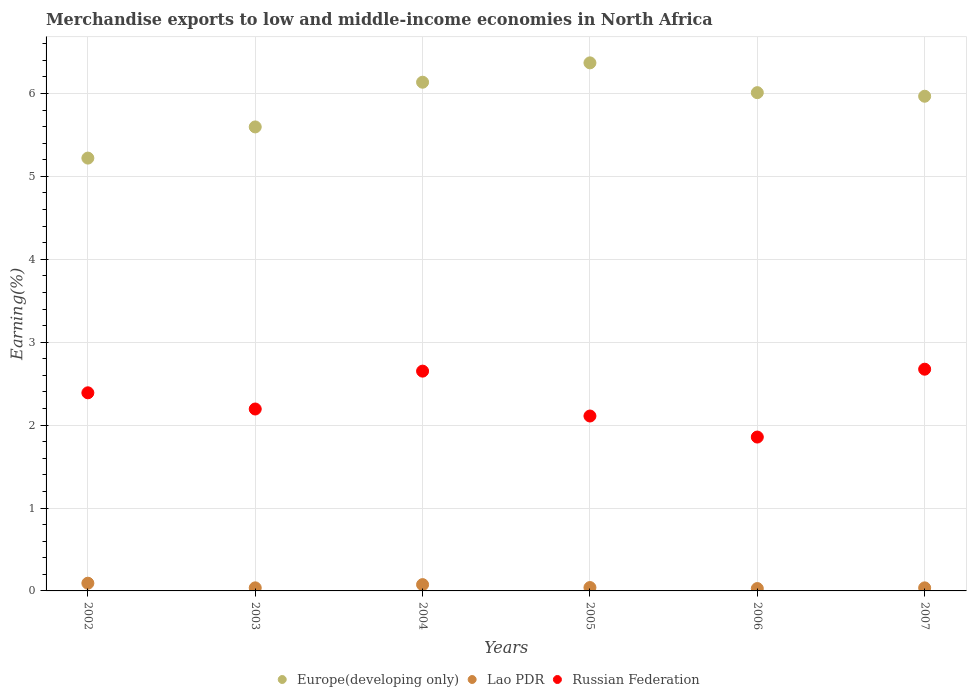Is the number of dotlines equal to the number of legend labels?
Offer a terse response. Yes. What is the percentage of amount earned from merchandise exports in Lao PDR in 2002?
Offer a very short reply. 0.09. Across all years, what is the maximum percentage of amount earned from merchandise exports in Lao PDR?
Offer a terse response. 0.09. Across all years, what is the minimum percentage of amount earned from merchandise exports in Lao PDR?
Give a very brief answer. 0.03. What is the total percentage of amount earned from merchandise exports in Russian Federation in the graph?
Keep it short and to the point. 13.87. What is the difference between the percentage of amount earned from merchandise exports in Europe(developing only) in 2004 and that in 2005?
Your response must be concise. -0.23. What is the difference between the percentage of amount earned from merchandise exports in Europe(developing only) in 2002 and the percentage of amount earned from merchandise exports in Lao PDR in 2007?
Your response must be concise. 5.18. What is the average percentage of amount earned from merchandise exports in Russian Federation per year?
Make the answer very short. 2.31. In the year 2005, what is the difference between the percentage of amount earned from merchandise exports in Europe(developing only) and percentage of amount earned from merchandise exports in Lao PDR?
Your answer should be compact. 6.33. What is the ratio of the percentage of amount earned from merchandise exports in Russian Federation in 2005 to that in 2007?
Make the answer very short. 0.79. Is the percentage of amount earned from merchandise exports in Russian Federation in 2002 less than that in 2006?
Your response must be concise. No. Is the difference between the percentage of amount earned from merchandise exports in Europe(developing only) in 2002 and 2005 greater than the difference between the percentage of amount earned from merchandise exports in Lao PDR in 2002 and 2005?
Your answer should be compact. No. What is the difference between the highest and the second highest percentage of amount earned from merchandise exports in Russian Federation?
Provide a short and direct response. 0.02. What is the difference between the highest and the lowest percentage of amount earned from merchandise exports in Europe(developing only)?
Your response must be concise. 1.15. Does the percentage of amount earned from merchandise exports in Lao PDR monotonically increase over the years?
Your response must be concise. No. Is the percentage of amount earned from merchandise exports in Europe(developing only) strictly greater than the percentage of amount earned from merchandise exports in Lao PDR over the years?
Offer a very short reply. Yes. Is the percentage of amount earned from merchandise exports in Lao PDR strictly less than the percentage of amount earned from merchandise exports in Europe(developing only) over the years?
Offer a very short reply. Yes. How many dotlines are there?
Your answer should be very brief. 3. How many years are there in the graph?
Keep it short and to the point. 6. Are the values on the major ticks of Y-axis written in scientific E-notation?
Offer a very short reply. No. Does the graph contain grids?
Offer a terse response. Yes. What is the title of the graph?
Keep it short and to the point. Merchandise exports to low and middle-income economies in North Africa. What is the label or title of the Y-axis?
Your answer should be compact. Earning(%). What is the Earning(%) in Europe(developing only) in 2002?
Your response must be concise. 5.22. What is the Earning(%) in Lao PDR in 2002?
Your answer should be very brief. 0.09. What is the Earning(%) in Russian Federation in 2002?
Your response must be concise. 2.39. What is the Earning(%) of Europe(developing only) in 2003?
Offer a terse response. 5.6. What is the Earning(%) in Lao PDR in 2003?
Make the answer very short. 0.04. What is the Earning(%) in Russian Federation in 2003?
Give a very brief answer. 2.19. What is the Earning(%) of Europe(developing only) in 2004?
Provide a short and direct response. 6.14. What is the Earning(%) in Lao PDR in 2004?
Offer a very short reply. 0.08. What is the Earning(%) of Russian Federation in 2004?
Ensure brevity in your answer.  2.65. What is the Earning(%) of Europe(developing only) in 2005?
Offer a terse response. 6.37. What is the Earning(%) in Lao PDR in 2005?
Offer a very short reply. 0.04. What is the Earning(%) of Russian Federation in 2005?
Ensure brevity in your answer.  2.11. What is the Earning(%) of Europe(developing only) in 2006?
Offer a very short reply. 6.01. What is the Earning(%) in Lao PDR in 2006?
Your response must be concise. 0.03. What is the Earning(%) of Russian Federation in 2006?
Give a very brief answer. 1.86. What is the Earning(%) of Europe(developing only) in 2007?
Keep it short and to the point. 5.97. What is the Earning(%) of Lao PDR in 2007?
Offer a terse response. 0.04. What is the Earning(%) of Russian Federation in 2007?
Give a very brief answer. 2.67. Across all years, what is the maximum Earning(%) in Europe(developing only)?
Offer a terse response. 6.37. Across all years, what is the maximum Earning(%) in Lao PDR?
Offer a very short reply. 0.09. Across all years, what is the maximum Earning(%) of Russian Federation?
Your answer should be very brief. 2.67. Across all years, what is the minimum Earning(%) of Europe(developing only)?
Your response must be concise. 5.22. Across all years, what is the minimum Earning(%) in Lao PDR?
Keep it short and to the point. 0.03. Across all years, what is the minimum Earning(%) of Russian Federation?
Your response must be concise. 1.86. What is the total Earning(%) of Europe(developing only) in the graph?
Your answer should be very brief. 35.3. What is the total Earning(%) in Lao PDR in the graph?
Make the answer very short. 0.31. What is the total Earning(%) in Russian Federation in the graph?
Make the answer very short. 13.87. What is the difference between the Earning(%) of Europe(developing only) in 2002 and that in 2003?
Keep it short and to the point. -0.38. What is the difference between the Earning(%) of Lao PDR in 2002 and that in 2003?
Provide a short and direct response. 0.06. What is the difference between the Earning(%) of Russian Federation in 2002 and that in 2003?
Your response must be concise. 0.2. What is the difference between the Earning(%) in Europe(developing only) in 2002 and that in 2004?
Ensure brevity in your answer.  -0.92. What is the difference between the Earning(%) of Lao PDR in 2002 and that in 2004?
Ensure brevity in your answer.  0.02. What is the difference between the Earning(%) in Russian Federation in 2002 and that in 2004?
Offer a very short reply. -0.26. What is the difference between the Earning(%) of Europe(developing only) in 2002 and that in 2005?
Your response must be concise. -1.15. What is the difference between the Earning(%) of Lao PDR in 2002 and that in 2005?
Provide a short and direct response. 0.05. What is the difference between the Earning(%) of Russian Federation in 2002 and that in 2005?
Make the answer very short. 0.28. What is the difference between the Earning(%) in Europe(developing only) in 2002 and that in 2006?
Offer a very short reply. -0.79. What is the difference between the Earning(%) in Lao PDR in 2002 and that in 2006?
Your answer should be compact. 0.06. What is the difference between the Earning(%) of Russian Federation in 2002 and that in 2006?
Your response must be concise. 0.53. What is the difference between the Earning(%) of Europe(developing only) in 2002 and that in 2007?
Offer a very short reply. -0.75. What is the difference between the Earning(%) in Lao PDR in 2002 and that in 2007?
Offer a terse response. 0.06. What is the difference between the Earning(%) in Russian Federation in 2002 and that in 2007?
Provide a short and direct response. -0.28. What is the difference between the Earning(%) of Europe(developing only) in 2003 and that in 2004?
Offer a terse response. -0.54. What is the difference between the Earning(%) of Lao PDR in 2003 and that in 2004?
Provide a succinct answer. -0.04. What is the difference between the Earning(%) in Russian Federation in 2003 and that in 2004?
Ensure brevity in your answer.  -0.46. What is the difference between the Earning(%) in Europe(developing only) in 2003 and that in 2005?
Offer a terse response. -0.77. What is the difference between the Earning(%) of Lao PDR in 2003 and that in 2005?
Your answer should be compact. -0. What is the difference between the Earning(%) of Russian Federation in 2003 and that in 2005?
Your response must be concise. 0.08. What is the difference between the Earning(%) in Europe(developing only) in 2003 and that in 2006?
Your answer should be compact. -0.41. What is the difference between the Earning(%) in Lao PDR in 2003 and that in 2006?
Make the answer very short. 0.01. What is the difference between the Earning(%) in Russian Federation in 2003 and that in 2006?
Provide a succinct answer. 0.34. What is the difference between the Earning(%) of Europe(developing only) in 2003 and that in 2007?
Your answer should be very brief. -0.37. What is the difference between the Earning(%) in Lao PDR in 2003 and that in 2007?
Your answer should be very brief. 0. What is the difference between the Earning(%) of Russian Federation in 2003 and that in 2007?
Provide a succinct answer. -0.48. What is the difference between the Earning(%) in Europe(developing only) in 2004 and that in 2005?
Give a very brief answer. -0.23. What is the difference between the Earning(%) of Lao PDR in 2004 and that in 2005?
Make the answer very short. 0.04. What is the difference between the Earning(%) of Russian Federation in 2004 and that in 2005?
Give a very brief answer. 0.54. What is the difference between the Earning(%) in Europe(developing only) in 2004 and that in 2006?
Offer a terse response. 0.13. What is the difference between the Earning(%) of Lao PDR in 2004 and that in 2006?
Keep it short and to the point. 0.05. What is the difference between the Earning(%) in Russian Federation in 2004 and that in 2006?
Make the answer very short. 0.8. What is the difference between the Earning(%) in Europe(developing only) in 2004 and that in 2007?
Give a very brief answer. 0.17. What is the difference between the Earning(%) of Lao PDR in 2004 and that in 2007?
Offer a very short reply. 0.04. What is the difference between the Earning(%) in Russian Federation in 2004 and that in 2007?
Your answer should be compact. -0.02. What is the difference between the Earning(%) in Europe(developing only) in 2005 and that in 2006?
Make the answer very short. 0.36. What is the difference between the Earning(%) of Lao PDR in 2005 and that in 2006?
Your answer should be compact. 0.01. What is the difference between the Earning(%) of Russian Federation in 2005 and that in 2006?
Your answer should be compact. 0.25. What is the difference between the Earning(%) of Europe(developing only) in 2005 and that in 2007?
Your answer should be compact. 0.4. What is the difference between the Earning(%) of Lao PDR in 2005 and that in 2007?
Your answer should be compact. 0. What is the difference between the Earning(%) of Russian Federation in 2005 and that in 2007?
Your response must be concise. -0.56. What is the difference between the Earning(%) of Europe(developing only) in 2006 and that in 2007?
Ensure brevity in your answer.  0.04. What is the difference between the Earning(%) in Lao PDR in 2006 and that in 2007?
Give a very brief answer. -0.01. What is the difference between the Earning(%) in Russian Federation in 2006 and that in 2007?
Provide a short and direct response. -0.82. What is the difference between the Earning(%) of Europe(developing only) in 2002 and the Earning(%) of Lao PDR in 2003?
Keep it short and to the point. 5.18. What is the difference between the Earning(%) in Europe(developing only) in 2002 and the Earning(%) in Russian Federation in 2003?
Your response must be concise. 3.03. What is the difference between the Earning(%) in Lao PDR in 2002 and the Earning(%) in Russian Federation in 2003?
Your answer should be very brief. -2.1. What is the difference between the Earning(%) of Europe(developing only) in 2002 and the Earning(%) of Lao PDR in 2004?
Give a very brief answer. 5.14. What is the difference between the Earning(%) of Europe(developing only) in 2002 and the Earning(%) of Russian Federation in 2004?
Your response must be concise. 2.57. What is the difference between the Earning(%) in Lao PDR in 2002 and the Earning(%) in Russian Federation in 2004?
Your response must be concise. -2.56. What is the difference between the Earning(%) in Europe(developing only) in 2002 and the Earning(%) in Lao PDR in 2005?
Make the answer very short. 5.18. What is the difference between the Earning(%) in Europe(developing only) in 2002 and the Earning(%) in Russian Federation in 2005?
Your answer should be very brief. 3.11. What is the difference between the Earning(%) in Lao PDR in 2002 and the Earning(%) in Russian Federation in 2005?
Your answer should be very brief. -2.02. What is the difference between the Earning(%) in Europe(developing only) in 2002 and the Earning(%) in Lao PDR in 2006?
Provide a succinct answer. 5.19. What is the difference between the Earning(%) of Europe(developing only) in 2002 and the Earning(%) of Russian Federation in 2006?
Ensure brevity in your answer.  3.36. What is the difference between the Earning(%) in Lao PDR in 2002 and the Earning(%) in Russian Federation in 2006?
Give a very brief answer. -1.76. What is the difference between the Earning(%) of Europe(developing only) in 2002 and the Earning(%) of Lao PDR in 2007?
Your answer should be compact. 5.18. What is the difference between the Earning(%) in Europe(developing only) in 2002 and the Earning(%) in Russian Federation in 2007?
Make the answer very short. 2.55. What is the difference between the Earning(%) in Lao PDR in 2002 and the Earning(%) in Russian Federation in 2007?
Offer a very short reply. -2.58. What is the difference between the Earning(%) of Europe(developing only) in 2003 and the Earning(%) of Lao PDR in 2004?
Your response must be concise. 5.52. What is the difference between the Earning(%) of Europe(developing only) in 2003 and the Earning(%) of Russian Federation in 2004?
Offer a very short reply. 2.95. What is the difference between the Earning(%) in Lao PDR in 2003 and the Earning(%) in Russian Federation in 2004?
Your answer should be very brief. -2.61. What is the difference between the Earning(%) of Europe(developing only) in 2003 and the Earning(%) of Lao PDR in 2005?
Give a very brief answer. 5.56. What is the difference between the Earning(%) in Europe(developing only) in 2003 and the Earning(%) in Russian Federation in 2005?
Offer a very short reply. 3.49. What is the difference between the Earning(%) in Lao PDR in 2003 and the Earning(%) in Russian Federation in 2005?
Offer a terse response. -2.07. What is the difference between the Earning(%) of Europe(developing only) in 2003 and the Earning(%) of Lao PDR in 2006?
Provide a short and direct response. 5.57. What is the difference between the Earning(%) in Europe(developing only) in 2003 and the Earning(%) in Russian Federation in 2006?
Your response must be concise. 3.74. What is the difference between the Earning(%) of Lao PDR in 2003 and the Earning(%) of Russian Federation in 2006?
Your answer should be compact. -1.82. What is the difference between the Earning(%) in Europe(developing only) in 2003 and the Earning(%) in Lao PDR in 2007?
Offer a very short reply. 5.56. What is the difference between the Earning(%) in Europe(developing only) in 2003 and the Earning(%) in Russian Federation in 2007?
Provide a succinct answer. 2.92. What is the difference between the Earning(%) in Lao PDR in 2003 and the Earning(%) in Russian Federation in 2007?
Your response must be concise. -2.64. What is the difference between the Earning(%) of Europe(developing only) in 2004 and the Earning(%) of Lao PDR in 2005?
Keep it short and to the point. 6.09. What is the difference between the Earning(%) of Europe(developing only) in 2004 and the Earning(%) of Russian Federation in 2005?
Your answer should be very brief. 4.03. What is the difference between the Earning(%) in Lao PDR in 2004 and the Earning(%) in Russian Federation in 2005?
Your answer should be compact. -2.03. What is the difference between the Earning(%) of Europe(developing only) in 2004 and the Earning(%) of Lao PDR in 2006?
Your answer should be compact. 6.11. What is the difference between the Earning(%) in Europe(developing only) in 2004 and the Earning(%) in Russian Federation in 2006?
Provide a succinct answer. 4.28. What is the difference between the Earning(%) of Lao PDR in 2004 and the Earning(%) of Russian Federation in 2006?
Ensure brevity in your answer.  -1.78. What is the difference between the Earning(%) in Europe(developing only) in 2004 and the Earning(%) in Lao PDR in 2007?
Offer a very short reply. 6.1. What is the difference between the Earning(%) of Europe(developing only) in 2004 and the Earning(%) of Russian Federation in 2007?
Make the answer very short. 3.46. What is the difference between the Earning(%) of Lao PDR in 2004 and the Earning(%) of Russian Federation in 2007?
Ensure brevity in your answer.  -2.6. What is the difference between the Earning(%) of Europe(developing only) in 2005 and the Earning(%) of Lao PDR in 2006?
Your answer should be very brief. 6.34. What is the difference between the Earning(%) in Europe(developing only) in 2005 and the Earning(%) in Russian Federation in 2006?
Give a very brief answer. 4.51. What is the difference between the Earning(%) of Lao PDR in 2005 and the Earning(%) of Russian Federation in 2006?
Your answer should be very brief. -1.82. What is the difference between the Earning(%) in Europe(developing only) in 2005 and the Earning(%) in Lao PDR in 2007?
Your response must be concise. 6.33. What is the difference between the Earning(%) of Europe(developing only) in 2005 and the Earning(%) of Russian Federation in 2007?
Keep it short and to the point. 3.69. What is the difference between the Earning(%) in Lao PDR in 2005 and the Earning(%) in Russian Federation in 2007?
Keep it short and to the point. -2.63. What is the difference between the Earning(%) in Europe(developing only) in 2006 and the Earning(%) in Lao PDR in 2007?
Offer a terse response. 5.97. What is the difference between the Earning(%) of Europe(developing only) in 2006 and the Earning(%) of Russian Federation in 2007?
Provide a short and direct response. 3.34. What is the difference between the Earning(%) of Lao PDR in 2006 and the Earning(%) of Russian Federation in 2007?
Offer a terse response. -2.65. What is the average Earning(%) of Europe(developing only) per year?
Offer a very short reply. 5.88. What is the average Earning(%) of Lao PDR per year?
Your answer should be compact. 0.05. What is the average Earning(%) of Russian Federation per year?
Keep it short and to the point. 2.31. In the year 2002, what is the difference between the Earning(%) of Europe(developing only) and Earning(%) of Lao PDR?
Provide a succinct answer. 5.13. In the year 2002, what is the difference between the Earning(%) of Europe(developing only) and Earning(%) of Russian Federation?
Give a very brief answer. 2.83. In the year 2002, what is the difference between the Earning(%) of Lao PDR and Earning(%) of Russian Federation?
Keep it short and to the point. -2.3. In the year 2003, what is the difference between the Earning(%) in Europe(developing only) and Earning(%) in Lao PDR?
Your answer should be very brief. 5.56. In the year 2003, what is the difference between the Earning(%) in Europe(developing only) and Earning(%) in Russian Federation?
Your answer should be compact. 3.4. In the year 2003, what is the difference between the Earning(%) in Lao PDR and Earning(%) in Russian Federation?
Provide a succinct answer. -2.16. In the year 2004, what is the difference between the Earning(%) in Europe(developing only) and Earning(%) in Lao PDR?
Provide a succinct answer. 6.06. In the year 2004, what is the difference between the Earning(%) in Europe(developing only) and Earning(%) in Russian Federation?
Ensure brevity in your answer.  3.48. In the year 2004, what is the difference between the Earning(%) in Lao PDR and Earning(%) in Russian Federation?
Keep it short and to the point. -2.57. In the year 2005, what is the difference between the Earning(%) in Europe(developing only) and Earning(%) in Lao PDR?
Offer a very short reply. 6.33. In the year 2005, what is the difference between the Earning(%) in Europe(developing only) and Earning(%) in Russian Federation?
Give a very brief answer. 4.26. In the year 2005, what is the difference between the Earning(%) of Lao PDR and Earning(%) of Russian Federation?
Your response must be concise. -2.07. In the year 2006, what is the difference between the Earning(%) in Europe(developing only) and Earning(%) in Lao PDR?
Provide a succinct answer. 5.98. In the year 2006, what is the difference between the Earning(%) in Europe(developing only) and Earning(%) in Russian Federation?
Make the answer very short. 4.15. In the year 2006, what is the difference between the Earning(%) of Lao PDR and Earning(%) of Russian Federation?
Make the answer very short. -1.83. In the year 2007, what is the difference between the Earning(%) in Europe(developing only) and Earning(%) in Lao PDR?
Your response must be concise. 5.93. In the year 2007, what is the difference between the Earning(%) of Europe(developing only) and Earning(%) of Russian Federation?
Make the answer very short. 3.29. In the year 2007, what is the difference between the Earning(%) of Lao PDR and Earning(%) of Russian Federation?
Offer a terse response. -2.64. What is the ratio of the Earning(%) of Europe(developing only) in 2002 to that in 2003?
Provide a succinct answer. 0.93. What is the ratio of the Earning(%) of Lao PDR in 2002 to that in 2003?
Provide a succinct answer. 2.51. What is the ratio of the Earning(%) of Russian Federation in 2002 to that in 2003?
Provide a succinct answer. 1.09. What is the ratio of the Earning(%) of Europe(developing only) in 2002 to that in 2004?
Make the answer very short. 0.85. What is the ratio of the Earning(%) of Lao PDR in 2002 to that in 2004?
Your answer should be compact. 1.23. What is the ratio of the Earning(%) in Russian Federation in 2002 to that in 2004?
Offer a terse response. 0.9. What is the ratio of the Earning(%) in Europe(developing only) in 2002 to that in 2005?
Your answer should be very brief. 0.82. What is the ratio of the Earning(%) in Lao PDR in 2002 to that in 2005?
Your answer should be very brief. 2.29. What is the ratio of the Earning(%) in Russian Federation in 2002 to that in 2005?
Offer a very short reply. 1.13. What is the ratio of the Earning(%) of Europe(developing only) in 2002 to that in 2006?
Give a very brief answer. 0.87. What is the ratio of the Earning(%) in Lao PDR in 2002 to that in 2006?
Ensure brevity in your answer.  3.25. What is the ratio of the Earning(%) of Russian Federation in 2002 to that in 2006?
Offer a terse response. 1.29. What is the ratio of the Earning(%) in Europe(developing only) in 2002 to that in 2007?
Offer a terse response. 0.87. What is the ratio of the Earning(%) of Lao PDR in 2002 to that in 2007?
Your response must be concise. 2.52. What is the ratio of the Earning(%) of Russian Federation in 2002 to that in 2007?
Provide a short and direct response. 0.89. What is the ratio of the Earning(%) in Europe(developing only) in 2003 to that in 2004?
Your answer should be very brief. 0.91. What is the ratio of the Earning(%) in Lao PDR in 2003 to that in 2004?
Keep it short and to the point. 0.49. What is the ratio of the Earning(%) of Russian Federation in 2003 to that in 2004?
Provide a succinct answer. 0.83. What is the ratio of the Earning(%) in Europe(developing only) in 2003 to that in 2005?
Provide a succinct answer. 0.88. What is the ratio of the Earning(%) of Lao PDR in 2003 to that in 2005?
Make the answer very short. 0.91. What is the ratio of the Earning(%) of Russian Federation in 2003 to that in 2005?
Your answer should be compact. 1.04. What is the ratio of the Earning(%) in Europe(developing only) in 2003 to that in 2006?
Give a very brief answer. 0.93. What is the ratio of the Earning(%) in Lao PDR in 2003 to that in 2006?
Offer a terse response. 1.29. What is the ratio of the Earning(%) in Russian Federation in 2003 to that in 2006?
Ensure brevity in your answer.  1.18. What is the ratio of the Earning(%) of Europe(developing only) in 2003 to that in 2007?
Ensure brevity in your answer.  0.94. What is the ratio of the Earning(%) of Lao PDR in 2003 to that in 2007?
Ensure brevity in your answer.  1. What is the ratio of the Earning(%) of Russian Federation in 2003 to that in 2007?
Provide a short and direct response. 0.82. What is the ratio of the Earning(%) of Europe(developing only) in 2004 to that in 2005?
Ensure brevity in your answer.  0.96. What is the ratio of the Earning(%) in Lao PDR in 2004 to that in 2005?
Ensure brevity in your answer.  1.87. What is the ratio of the Earning(%) in Russian Federation in 2004 to that in 2005?
Your response must be concise. 1.26. What is the ratio of the Earning(%) of Lao PDR in 2004 to that in 2006?
Give a very brief answer. 2.65. What is the ratio of the Earning(%) of Russian Federation in 2004 to that in 2006?
Your answer should be compact. 1.43. What is the ratio of the Earning(%) of Europe(developing only) in 2004 to that in 2007?
Provide a succinct answer. 1.03. What is the ratio of the Earning(%) in Lao PDR in 2004 to that in 2007?
Your answer should be compact. 2.06. What is the ratio of the Earning(%) in Europe(developing only) in 2005 to that in 2006?
Offer a terse response. 1.06. What is the ratio of the Earning(%) of Lao PDR in 2005 to that in 2006?
Provide a short and direct response. 1.42. What is the ratio of the Earning(%) in Russian Federation in 2005 to that in 2006?
Ensure brevity in your answer.  1.14. What is the ratio of the Earning(%) of Europe(developing only) in 2005 to that in 2007?
Your answer should be compact. 1.07. What is the ratio of the Earning(%) of Lao PDR in 2005 to that in 2007?
Make the answer very short. 1.1. What is the ratio of the Earning(%) in Russian Federation in 2005 to that in 2007?
Offer a very short reply. 0.79. What is the ratio of the Earning(%) of Europe(developing only) in 2006 to that in 2007?
Your answer should be very brief. 1.01. What is the ratio of the Earning(%) of Lao PDR in 2006 to that in 2007?
Offer a terse response. 0.78. What is the ratio of the Earning(%) in Russian Federation in 2006 to that in 2007?
Your answer should be very brief. 0.69. What is the difference between the highest and the second highest Earning(%) in Europe(developing only)?
Offer a very short reply. 0.23. What is the difference between the highest and the second highest Earning(%) in Lao PDR?
Ensure brevity in your answer.  0.02. What is the difference between the highest and the second highest Earning(%) in Russian Federation?
Keep it short and to the point. 0.02. What is the difference between the highest and the lowest Earning(%) of Europe(developing only)?
Provide a succinct answer. 1.15. What is the difference between the highest and the lowest Earning(%) in Lao PDR?
Your answer should be compact. 0.06. What is the difference between the highest and the lowest Earning(%) of Russian Federation?
Ensure brevity in your answer.  0.82. 